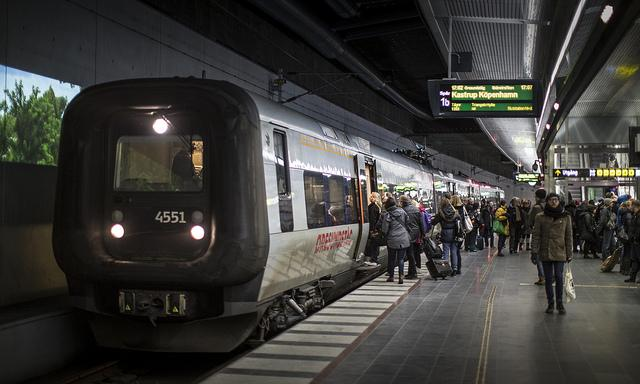What can be seen to the left of the train? Please explain your reasoning. trees. The objects to the left of the train have green leaves. 